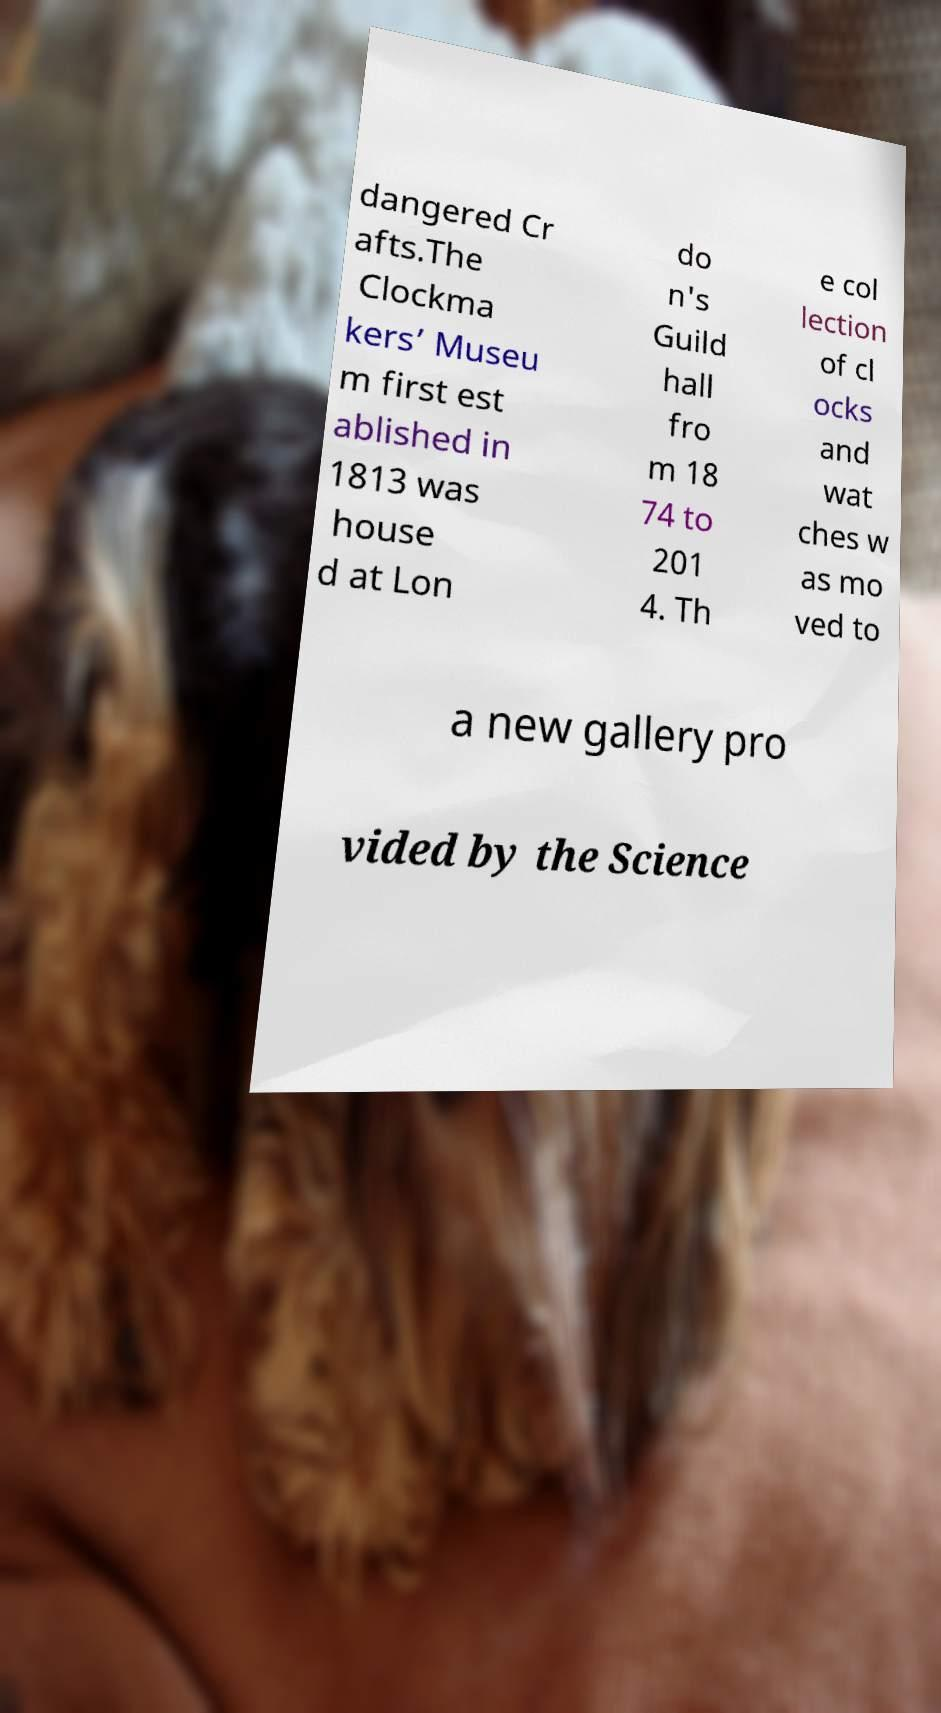There's text embedded in this image that I need extracted. Can you transcribe it verbatim? dangered Cr afts.The Clockma kers’ Museu m first est ablished in 1813 was house d at Lon do n's Guild hall fro m 18 74 to 201 4. Th e col lection of cl ocks and wat ches w as mo ved to a new gallery pro vided by the Science 